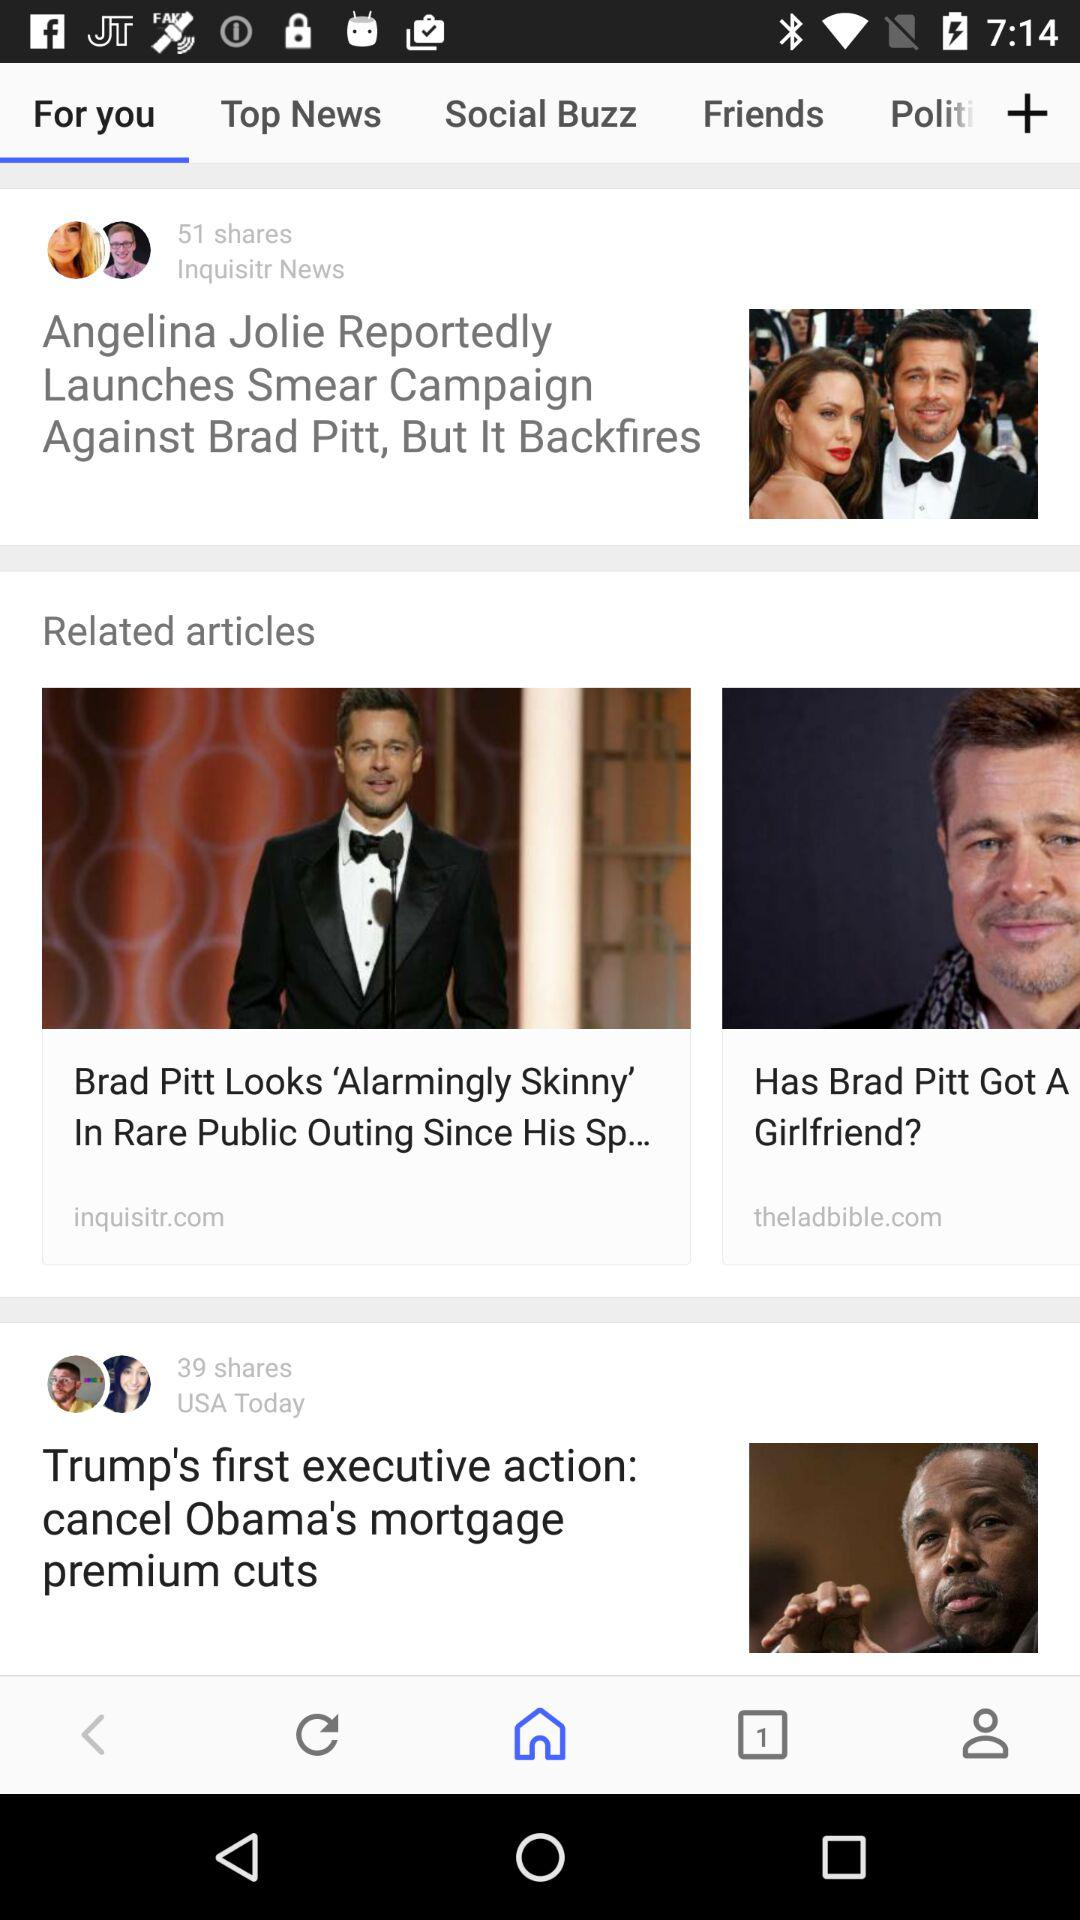How many shares does the article 'Trump's first executive action: cancel Obama's mortgage premium cuts' have?
Answer the question using a single word or phrase. 39 